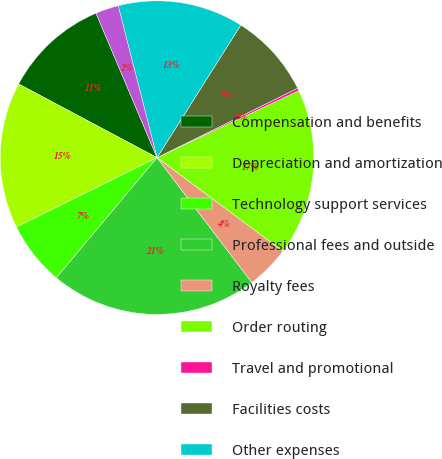<chart> <loc_0><loc_0><loc_500><loc_500><pie_chart><fcel>Compensation and benefits<fcel>Depreciation and amortization<fcel>Technology support services<fcel>Professional fees and outside<fcel>Royalty fees<fcel>Order routing<fcel>Travel and promotional<fcel>Facilities costs<fcel>Other expenses<fcel>Total operating expenses<nl><fcel>10.85%<fcel>15.08%<fcel>6.61%<fcel>21.43%<fcel>4.5%<fcel>17.2%<fcel>0.27%<fcel>8.73%<fcel>12.96%<fcel>2.38%<nl></chart> 